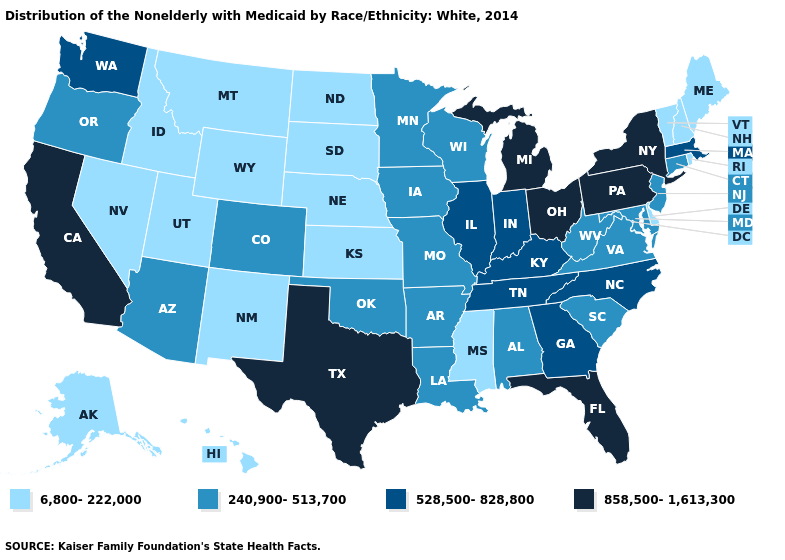Name the states that have a value in the range 858,500-1,613,300?
Short answer required. California, Florida, Michigan, New York, Ohio, Pennsylvania, Texas. What is the value of Louisiana?
Short answer required. 240,900-513,700. Among the states that border Washington , does Oregon have the lowest value?
Keep it brief. No. What is the highest value in the USA?
Keep it brief. 858,500-1,613,300. Name the states that have a value in the range 240,900-513,700?
Answer briefly. Alabama, Arizona, Arkansas, Colorado, Connecticut, Iowa, Louisiana, Maryland, Minnesota, Missouri, New Jersey, Oklahoma, Oregon, South Carolina, Virginia, West Virginia, Wisconsin. What is the value of Georgia?
Be succinct. 528,500-828,800. Does Alaska have a higher value than Maine?
Give a very brief answer. No. What is the highest value in states that border Maine?
Quick response, please. 6,800-222,000. Which states have the highest value in the USA?
Answer briefly. California, Florida, Michigan, New York, Ohio, Pennsylvania, Texas. What is the value of Louisiana?
Short answer required. 240,900-513,700. Name the states that have a value in the range 240,900-513,700?
Write a very short answer. Alabama, Arizona, Arkansas, Colorado, Connecticut, Iowa, Louisiana, Maryland, Minnesota, Missouri, New Jersey, Oklahoma, Oregon, South Carolina, Virginia, West Virginia, Wisconsin. Name the states that have a value in the range 528,500-828,800?
Give a very brief answer. Georgia, Illinois, Indiana, Kentucky, Massachusetts, North Carolina, Tennessee, Washington. Among the states that border New York , which have the highest value?
Be succinct. Pennsylvania. Among the states that border Maryland , does Delaware have the highest value?
Answer briefly. No. What is the value of Ohio?
Be succinct. 858,500-1,613,300. 